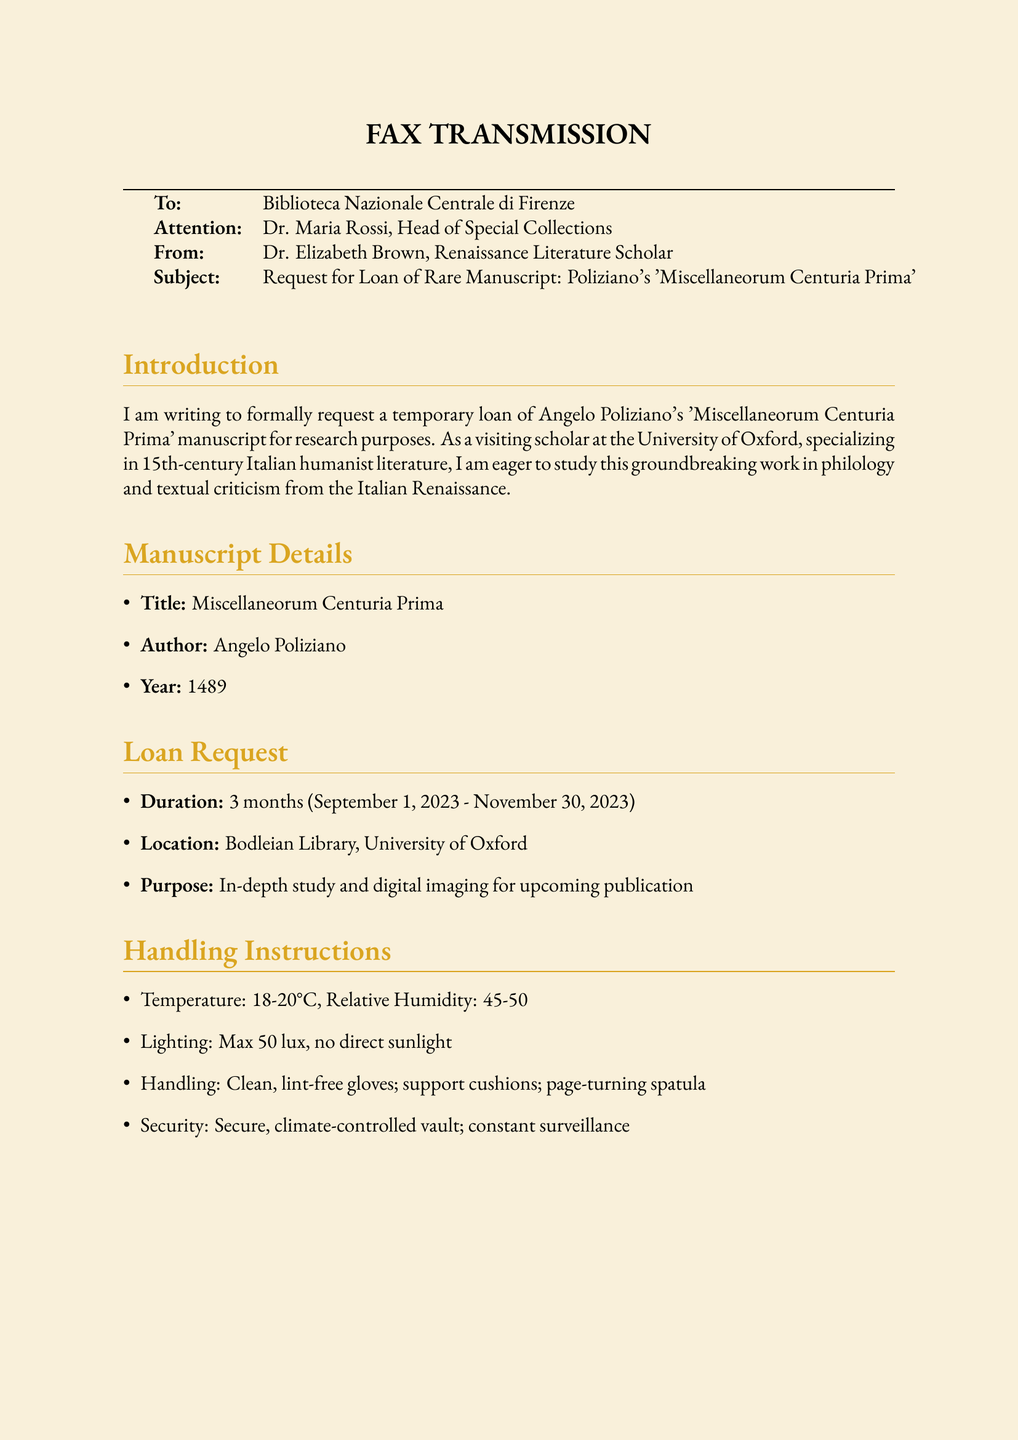What is the title of the manuscript requested? The title is explicitly stated in the manuscript details section.
Answer: Miscellaneorum Centuria Prima Who is the author of the manuscript? The author is mentioned in the manuscript details section.
Answer: Angelo Poliziano What is the duration of the loan request? The duration is specified in the loan request section.
Answer: 3 months Where will the manuscript be located during the loan? The location is provided in the loan request section.
Answer: Bodleian Library, University of Oxford What are the security measures mentioned for handling the manuscript? The security details are outlined in the handling instructions section.
Answer: Secure, climate-controlled vault; constant surveillance What temperature range is specified for handling the manuscript? The temperature range is included in the handling instructions.
Answer: 18-20°C What is the purpose of the loan request? The purpose is detailed in the loan request section.
Answer: In-depth study and digital imaging for upcoming publication Who is the recipient of the fax? The recipient is identified at the beginning of the document.
Answer: Biblioteca Nazionale Centrale di Firenze What is the name of the sender of the fax? The sender is specified at the beginning of the document.
Answer: Dr. Elizabeth Brown 